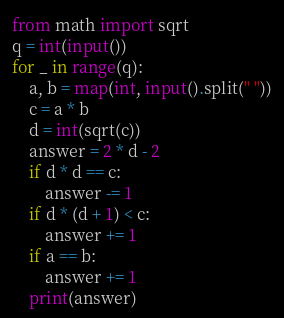<code> <loc_0><loc_0><loc_500><loc_500><_Python_>from math import sqrt
q = int(input())
for _ in range(q):
    a, b = map(int, input().split(" "))
    c = a * b
    d = int(sqrt(c))
    answer = 2 * d - 2
    if d * d == c:
        answer -= 1
    if d * (d + 1) < c:
        answer += 1
    if a == b:
        answer += 1
    print(answer)</code> 